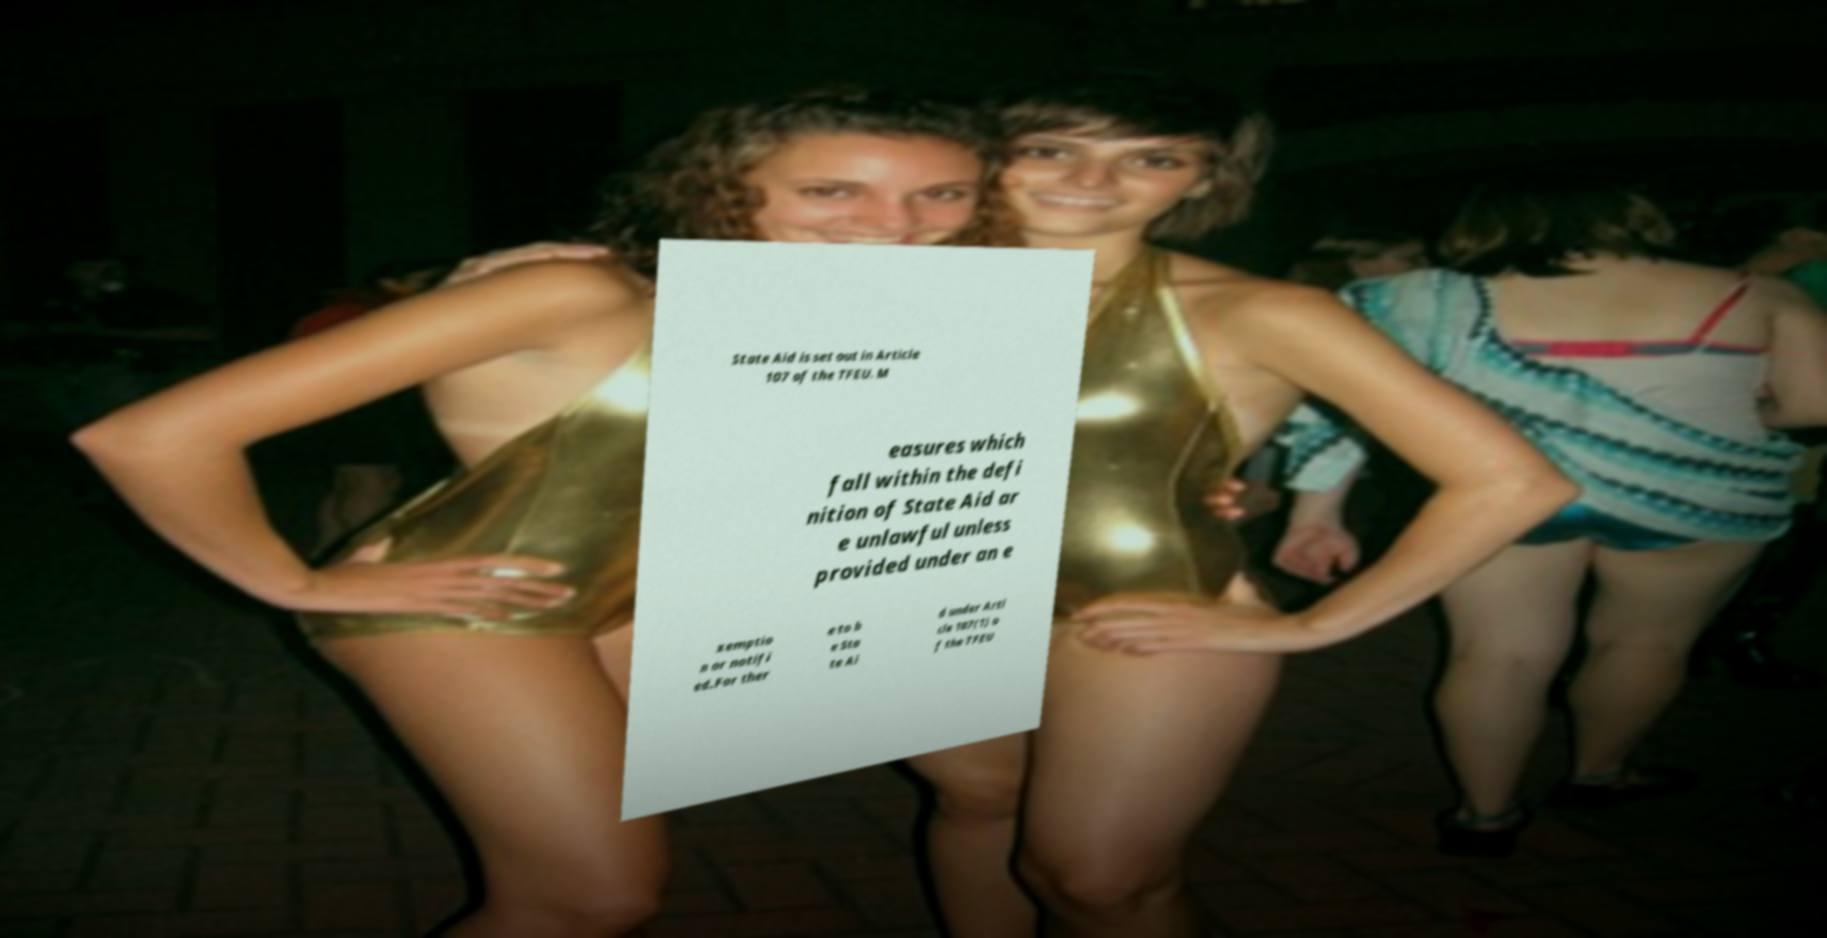What messages or text are displayed in this image? I need them in a readable, typed format. State Aid is set out in Article 107 of the TFEU. M easures which fall within the defi nition of State Aid ar e unlawful unless provided under an e xemptio n or notifi ed.For ther e to b e Sta te Ai d under Arti cle 107(1) o f the TFEU 